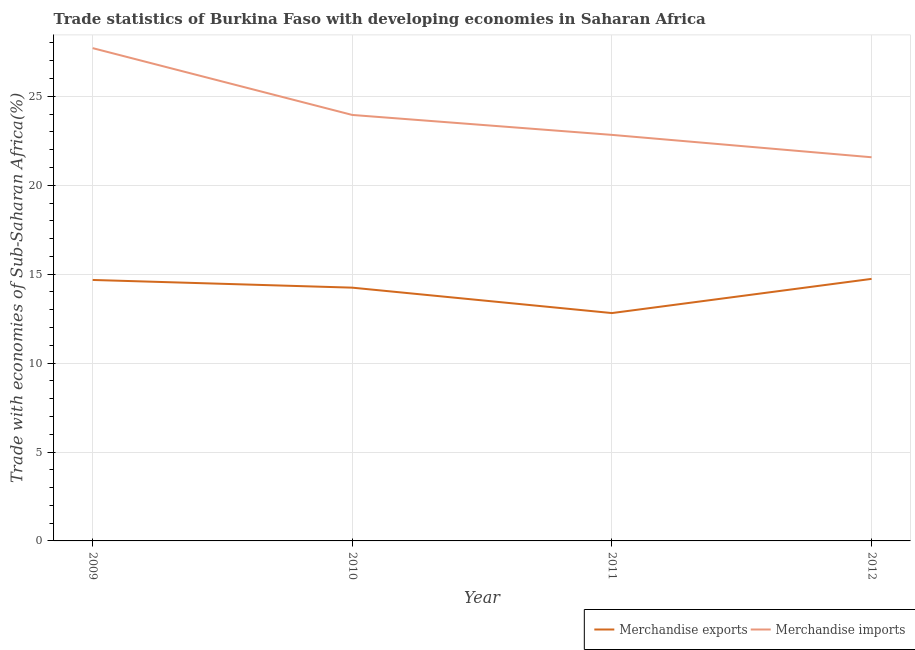How many different coloured lines are there?
Your response must be concise. 2. What is the merchandise imports in 2011?
Your response must be concise. 22.83. Across all years, what is the maximum merchandise exports?
Provide a succinct answer. 14.73. Across all years, what is the minimum merchandise imports?
Make the answer very short. 21.57. In which year was the merchandise imports minimum?
Provide a succinct answer. 2012. What is the total merchandise exports in the graph?
Your answer should be very brief. 56.46. What is the difference between the merchandise imports in 2011 and that in 2012?
Ensure brevity in your answer.  1.26. What is the difference between the merchandise exports in 2012 and the merchandise imports in 2010?
Your answer should be compact. -9.22. What is the average merchandise imports per year?
Offer a terse response. 24.02. In the year 2010, what is the difference between the merchandise imports and merchandise exports?
Offer a terse response. 9.71. In how many years, is the merchandise imports greater than 22 %?
Make the answer very short. 3. What is the ratio of the merchandise exports in 2009 to that in 2010?
Provide a succinct answer. 1.03. Is the merchandise imports in 2010 less than that in 2011?
Your answer should be very brief. No. What is the difference between the highest and the second highest merchandise exports?
Provide a succinct answer. 0.06. What is the difference between the highest and the lowest merchandise exports?
Offer a very short reply. 1.92. Does the merchandise exports monotonically increase over the years?
Your answer should be very brief. No. Is the merchandise imports strictly less than the merchandise exports over the years?
Ensure brevity in your answer.  No. How many lines are there?
Your response must be concise. 2. How many years are there in the graph?
Your answer should be compact. 4. What is the difference between two consecutive major ticks on the Y-axis?
Provide a short and direct response. 5. Does the graph contain any zero values?
Your answer should be very brief. No. Does the graph contain grids?
Your answer should be compact. Yes. What is the title of the graph?
Provide a short and direct response. Trade statistics of Burkina Faso with developing economies in Saharan Africa. Does "Mineral" appear as one of the legend labels in the graph?
Ensure brevity in your answer.  No. What is the label or title of the Y-axis?
Your answer should be compact. Trade with economies of Sub-Saharan Africa(%). What is the Trade with economies of Sub-Saharan Africa(%) in Merchandise exports in 2009?
Provide a succinct answer. 14.67. What is the Trade with economies of Sub-Saharan Africa(%) in Merchandise imports in 2009?
Your answer should be compact. 27.71. What is the Trade with economies of Sub-Saharan Africa(%) in Merchandise exports in 2010?
Your response must be concise. 14.24. What is the Trade with economies of Sub-Saharan Africa(%) of Merchandise imports in 2010?
Your answer should be very brief. 23.95. What is the Trade with economies of Sub-Saharan Africa(%) of Merchandise exports in 2011?
Your response must be concise. 12.81. What is the Trade with economies of Sub-Saharan Africa(%) of Merchandise imports in 2011?
Your answer should be compact. 22.83. What is the Trade with economies of Sub-Saharan Africa(%) of Merchandise exports in 2012?
Give a very brief answer. 14.73. What is the Trade with economies of Sub-Saharan Africa(%) of Merchandise imports in 2012?
Provide a succinct answer. 21.57. Across all years, what is the maximum Trade with economies of Sub-Saharan Africa(%) of Merchandise exports?
Provide a short and direct response. 14.73. Across all years, what is the maximum Trade with economies of Sub-Saharan Africa(%) of Merchandise imports?
Offer a terse response. 27.71. Across all years, what is the minimum Trade with economies of Sub-Saharan Africa(%) in Merchandise exports?
Provide a short and direct response. 12.81. Across all years, what is the minimum Trade with economies of Sub-Saharan Africa(%) of Merchandise imports?
Your answer should be very brief. 21.57. What is the total Trade with economies of Sub-Saharan Africa(%) of Merchandise exports in the graph?
Provide a short and direct response. 56.46. What is the total Trade with economies of Sub-Saharan Africa(%) of Merchandise imports in the graph?
Provide a short and direct response. 96.07. What is the difference between the Trade with economies of Sub-Saharan Africa(%) in Merchandise exports in 2009 and that in 2010?
Provide a short and direct response. 0.43. What is the difference between the Trade with economies of Sub-Saharan Africa(%) of Merchandise imports in 2009 and that in 2010?
Your answer should be compact. 3.76. What is the difference between the Trade with economies of Sub-Saharan Africa(%) in Merchandise exports in 2009 and that in 2011?
Make the answer very short. 1.86. What is the difference between the Trade with economies of Sub-Saharan Africa(%) of Merchandise imports in 2009 and that in 2011?
Make the answer very short. 4.88. What is the difference between the Trade with economies of Sub-Saharan Africa(%) of Merchandise exports in 2009 and that in 2012?
Offer a terse response. -0.06. What is the difference between the Trade with economies of Sub-Saharan Africa(%) in Merchandise imports in 2009 and that in 2012?
Make the answer very short. 6.14. What is the difference between the Trade with economies of Sub-Saharan Africa(%) in Merchandise exports in 2010 and that in 2011?
Your answer should be compact. 1.43. What is the difference between the Trade with economies of Sub-Saharan Africa(%) of Merchandise imports in 2010 and that in 2011?
Your answer should be very brief. 1.12. What is the difference between the Trade with economies of Sub-Saharan Africa(%) of Merchandise exports in 2010 and that in 2012?
Make the answer very short. -0.49. What is the difference between the Trade with economies of Sub-Saharan Africa(%) in Merchandise imports in 2010 and that in 2012?
Your answer should be compact. 2.38. What is the difference between the Trade with economies of Sub-Saharan Africa(%) of Merchandise exports in 2011 and that in 2012?
Make the answer very short. -1.92. What is the difference between the Trade with economies of Sub-Saharan Africa(%) in Merchandise imports in 2011 and that in 2012?
Offer a terse response. 1.26. What is the difference between the Trade with economies of Sub-Saharan Africa(%) of Merchandise exports in 2009 and the Trade with economies of Sub-Saharan Africa(%) of Merchandise imports in 2010?
Your answer should be very brief. -9.28. What is the difference between the Trade with economies of Sub-Saharan Africa(%) in Merchandise exports in 2009 and the Trade with economies of Sub-Saharan Africa(%) in Merchandise imports in 2011?
Provide a short and direct response. -8.16. What is the difference between the Trade with economies of Sub-Saharan Africa(%) in Merchandise exports in 2009 and the Trade with economies of Sub-Saharan Africa(%) in Merchandise imports in 2012?
Give a very brief answer. -6.9. What is the difference between the Trade with economies of Sub-Saharan Africa(%) of Merchandise exports in 2010 and the Trade with economies of Sub-Saharan Africa(%) of Merchandise imports in 2011?
Offer a very short reply. -8.59. What is the difference between the Trade with economies of Sub-Saharan Africa(%) of Merchandise exports in 2010 and the Trade with economies of Sub-Saharan Africa(%) of Merchandise imports in 2012?
Keep it short and to the point. -7.33. What is the difference between the Trade with economies of Sub-Saharan Africa(%) in Merchandise exports in 2011 and the Trade with economies of Sub-Saharan Africa(%) in Merchandise imports in 2012?
Give a very brief answer. -8.76. What is the average Trade with economies of Sub-Saharan Africa(%) in Merchandise exports per year?
Your answer should be very brief. 14.12. What is the average Trade with economies of Sub-Saharan Africa(%) in Merchandise imports per year?
Offer a terse response. 24.02. In the year 2009, what is the difference between the Trade with economies of Sub-Saharan Africa(%) in Merchandise exports and Trade with economies of Sub-Saharan Africa(%) in Merchandise imports?
Ensure brevity in your answer.  -13.04. In the year 2010, what is the difference between the Trade with economies of Sub-Saharan Africa(%) of Merchandise exports and Trade with economies of Sub-Saharan Africa(%) of Merchandise imports?
Offer a very short reply. -9.71. In the year 2011, what is the difference between the Trade with economies of Sub-Saharan Africa(%) in Merchandise exports and Trade with economies of Sub-Saharan Africa(%) in Merchandise imports?
Provide a succinct answer. -10.02. In the year 2012, what is the difference between the Trade with economies of Sub-Saharan Africa(%) in Merchandise exports and Trade with economies of Sub-Saharan Africa(%) in Merchandise imports?
Your response must be concise. -6.84. What is the ratio of the Trade with economies of Sub-Saharan Africa(%) in Merchandise exports in 2009 to that in 2010?
Your answer should be very brief. 1.03. What is the ratio of the Trade with economies of Sub-Saharan Africa(%) in Merchandise imports in 2009 to that in 2010?
Offer a very short reply. 1.16. What is the ratio of the Trade with economies of Sub-Saharan Africa(%) in Merchandise exports in 2009 to that in 2011?
Give a very brief answer. 1.15. What is the ratio of the Trade with economies of Sub-Saharan Africa(%) in Merchandise imports in 2009 to that in 2011?
Offer a very short reply. 1.21. What is the ratio of the Trade with economies of Sub-Saharan Africa(%) of Merchandise imports in 2009 to that in 2012?
Provide a succinct answer. 1.28. What is the ratio of the Trade with economies of Sub-Saharan Africa(%) in Merchandise exports in 2010 to that in 2011?
Provide a short and direct response. 1.11. What is the ratio of the Trade with economies of Sub-Saharan Africa(%) of Merchandise imports in 2010 to that in 2011?
Offer a terse response. 1.05. What is the ratio of the Trade with economies of Sub-Saharan Africa(%) in Merchandise exports in 2010 to that in 2012?
Your response must be concise. 0.97. What is the ratio of the Trade with economies of Sub-Saharan Africa(%) of Merchandise imports in 2010 to that in 2012?
Your answer should be very brief. 1.11. What is the ratio of the Trade with economies of Sub-Saharan Africa(%) in Merchandise exports in 2011 to that in 2012?
Your answer should be compact. 0.87. What is the ratio of the Trade with economies of Sub-Saharan Africa(%) in Merchandise imports in 2011 to that in 2012?
Provide a short and direct response. 1.06. What is the difference between the highest and the second highest Trade with economies of Sub-Saharan Africa(%) of Merchandise exports?
Keep it short and to the point. 0.06. What is the difference between the highest and the second highest Trade with economies of Sub-Saharan Africa(%) of Merchandise imports?
Ensure brevity in your answer.  3.76. What is the difference between the highest and the lowest Trade with economies of Sub-Saharan Africa(%) in Merchandise exports?
Offer a very short reply. 1.92. What is the difference between the highest and the lowest Trade with economies of Sub-Saharan Africa(%) in Merchandise imports?
Your response must be concise. 6.14. 